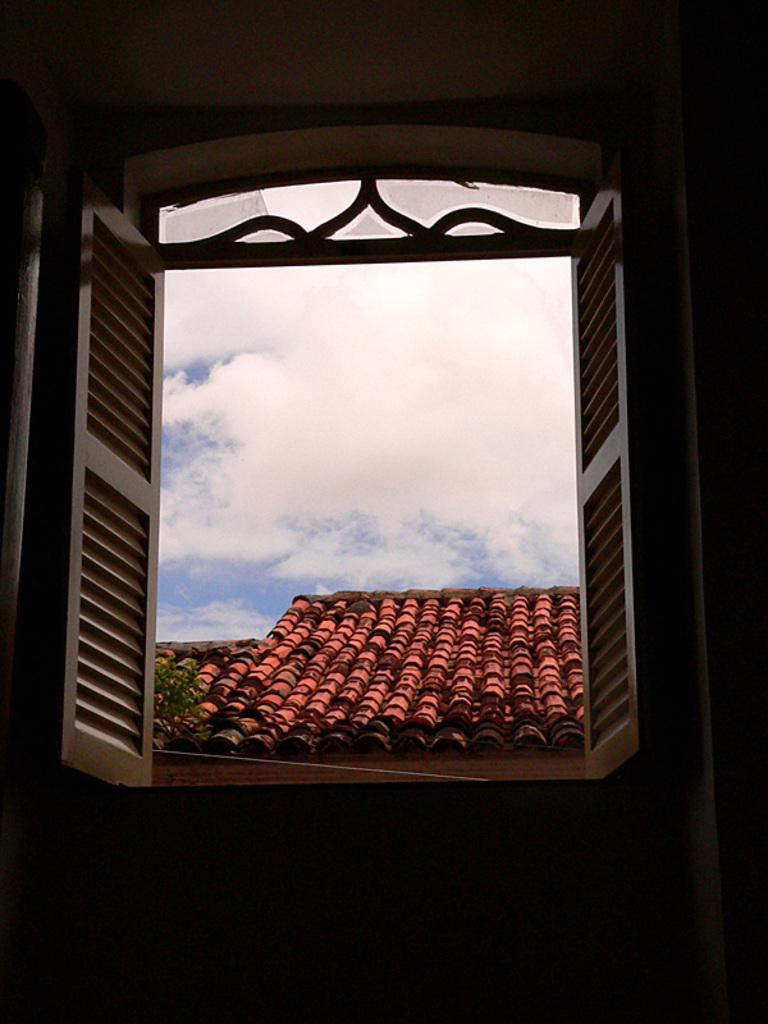What can be seen through the window in the image? Roofs, plants, and the sky are visible through the window in the image. What is the condition of the sky in the image? Clouds are present in the sky, which is visible through the window. Can you see a snail crawling on the roof through the window? There is no snail visible in the image, and it is not possible to determine if one is present on the roof. 